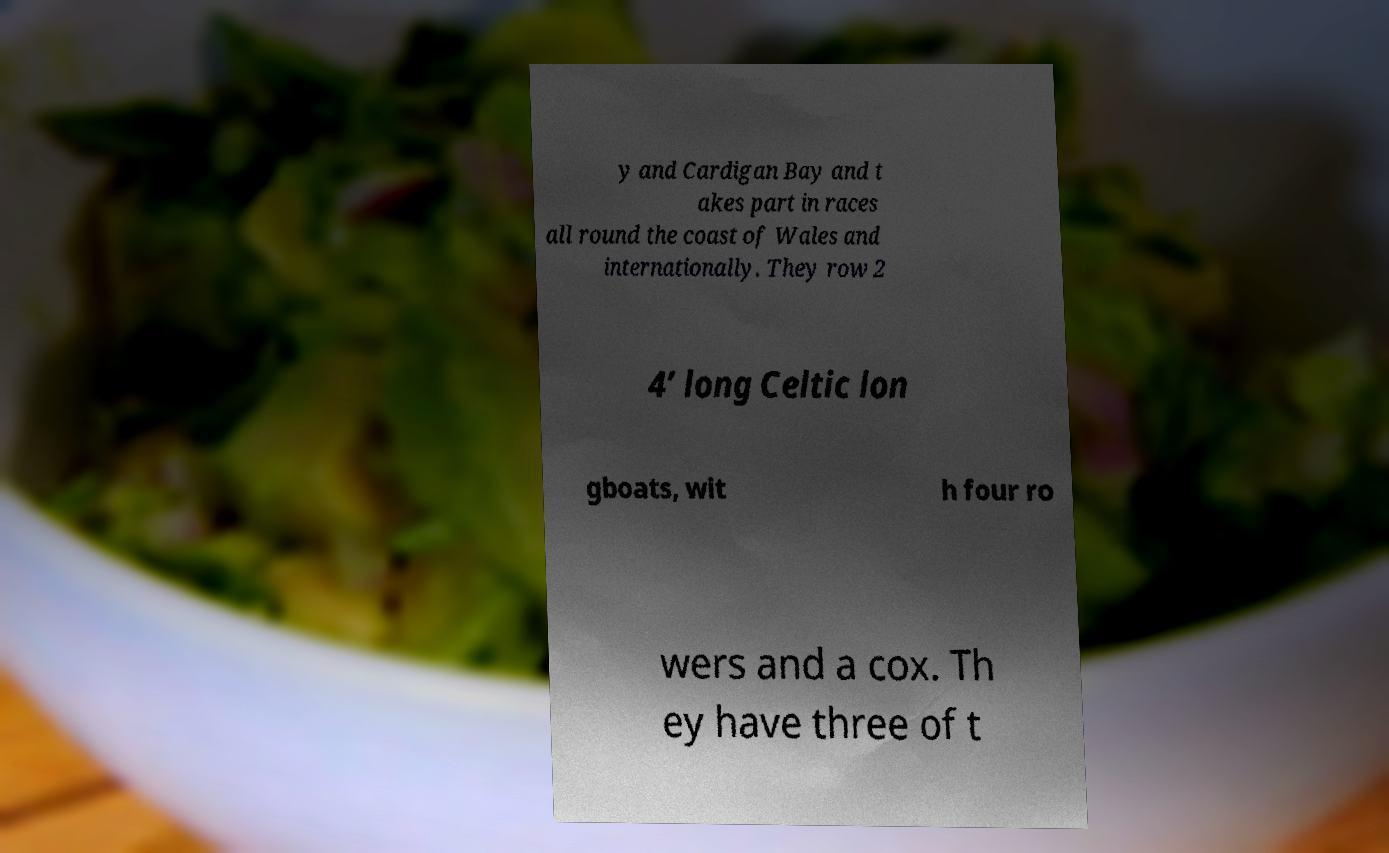Could you extract and type out the text from this image? y and Cardigan Bay and t akes part in races all round the coast of Wales and internationally. They row 2 4’ long Celtic lon gboats, wit h four ro wers and a cox. Th ey have three of t 